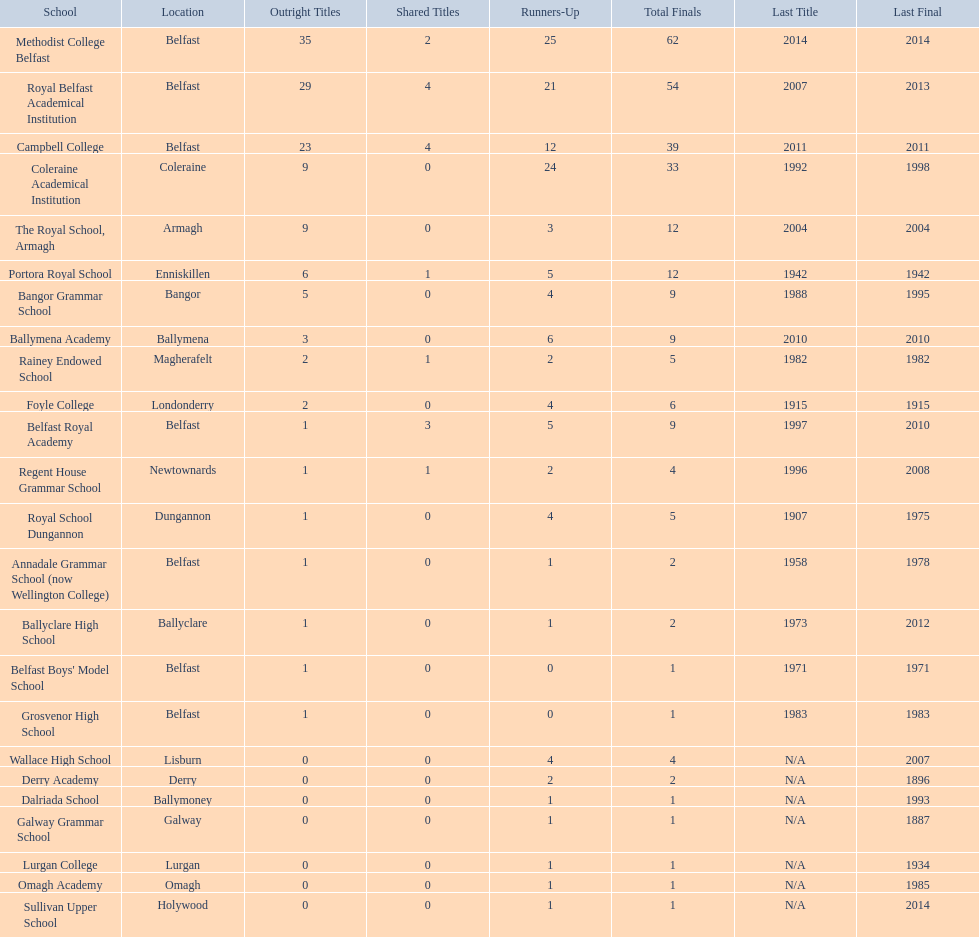What is the most recent win of campbell college? 2011. What is the most recent win of regent house grammar school? 1996. Which date is more recent? 2011. What is the name of the school with this date? Campbell College. 